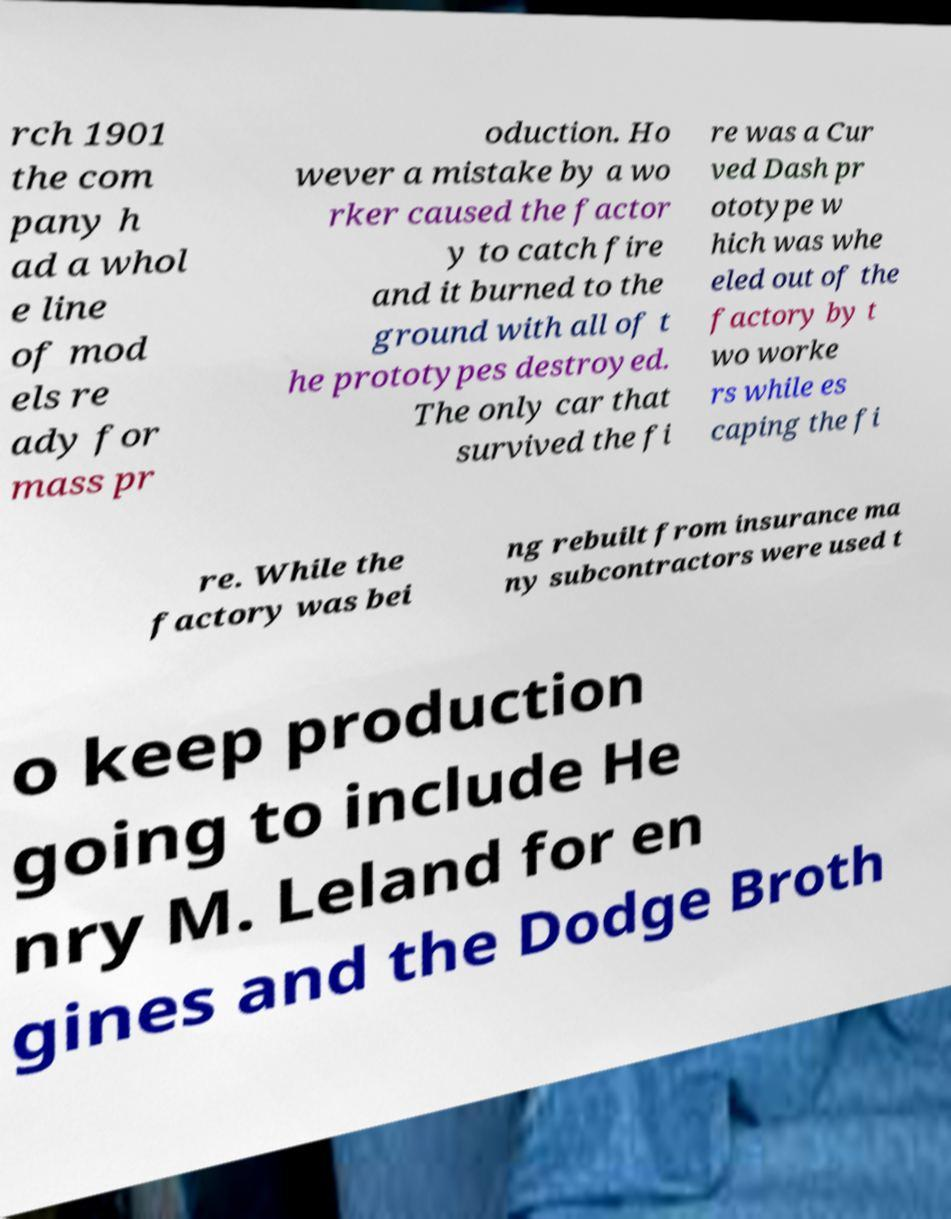Can you accurately transcribe the text from the provided image for me? rch 1901 the com pany h ad a whol e line of mod els re ady for mass pr oduction. Ho wever a mistake by a wo rker caused the factor y to catch fire and it burned to the ground with all of t he prototypes destroyed. The only car that survived the fi re was a Cur ved Dash pr ototype w hich was whe eled out of the factory by t wo worke rs while es caping the fi re. While the factory was bei ng rebuilt from insurance ma ny subcontractors were used t o keep production going to include He nry M. Leland for en gines and the Dodge Broth 